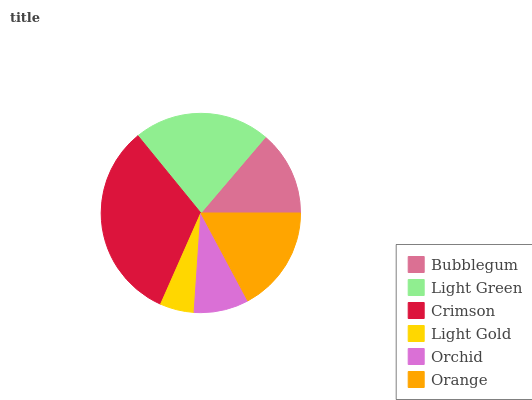Is Light Gold the minimum?
Answer yes or no. Yes. Is Crimson the maximum?
Answer yes or no. Yes. Is Light Green the minimum?
Answer yes or no. No. Is Light Green the maximum?
Answer yes or no. No. Is Light Green greater than Bubblegum?
Answer yes or no. Yes. Is Bubblegum less than Light Green?
Answer yes or no. Yes. Is Bubblegum greater than Light Green?
Answer yes or no. No. Is Light Green less than Bubblegum?
Answer yes or no. No. Is Orange the high median?
Answer yes or no. Yes. Is Bubblegum the low median?
Answer yes or no. Yes. Is Light Green the high median?
Answer yes or no. No. Is Light Gold the low median?
Answer yes or no. No. 